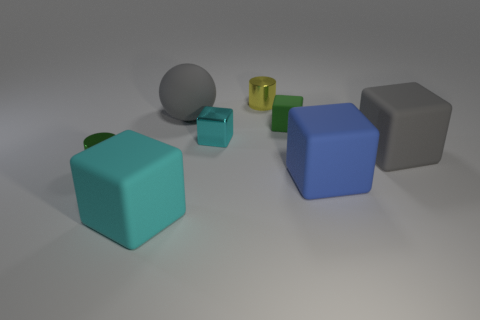What number of other metal cylinders are the same size as the yellow shiny cylinder?
Your response must be concise. 1. Are the sphere that is right of the green metallic object and the yellow object made of the same material?
Provide a succinct answer. No. Are there fewer large blue matte things left of the cyan matte block than small yellow balls?
Keep it short and to the point. No. What shape is the big gray thing on the right side of the big blue thing?
Give a very brief answer. Cube. There is a blue rubber object that is the same size as the cyan rubber object; what is its shape?
Make the answer very short. Cube. Is there a big gray object of the same shape as the yellow object?
Offer a terse response. No. Does the big gray object that is behind the large gray matte block have the same shape as the big gray rubber object to the right of the large gray sphere?
Offer a terse response. No. There is a cyan block that is the same size as the blue rubber block; what is it made of?
Give a very brief answer. Rubber. What number of other things are there of the same material as the blue cube
Provide a short and direct response. 4. What is the shape of the gray object that is in front of the large gray object on the left side of the small yellow metal thing?
Ensure brevity in your answer.  Cube. 